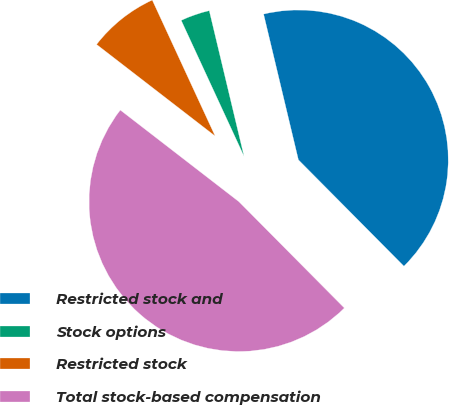Convert chart to OTSL. <chart><loc_0><loc_0><loc_500><loc_500><pie_chart><fcel>Restricted stock and<fcel>Stock options<fcel>Restricted stock<fcel>Total stock-based compensation<nl><fcel>41.3%<fcel>3.16%<fcel>7.64%<fcel>47.91%<nl></chart> 